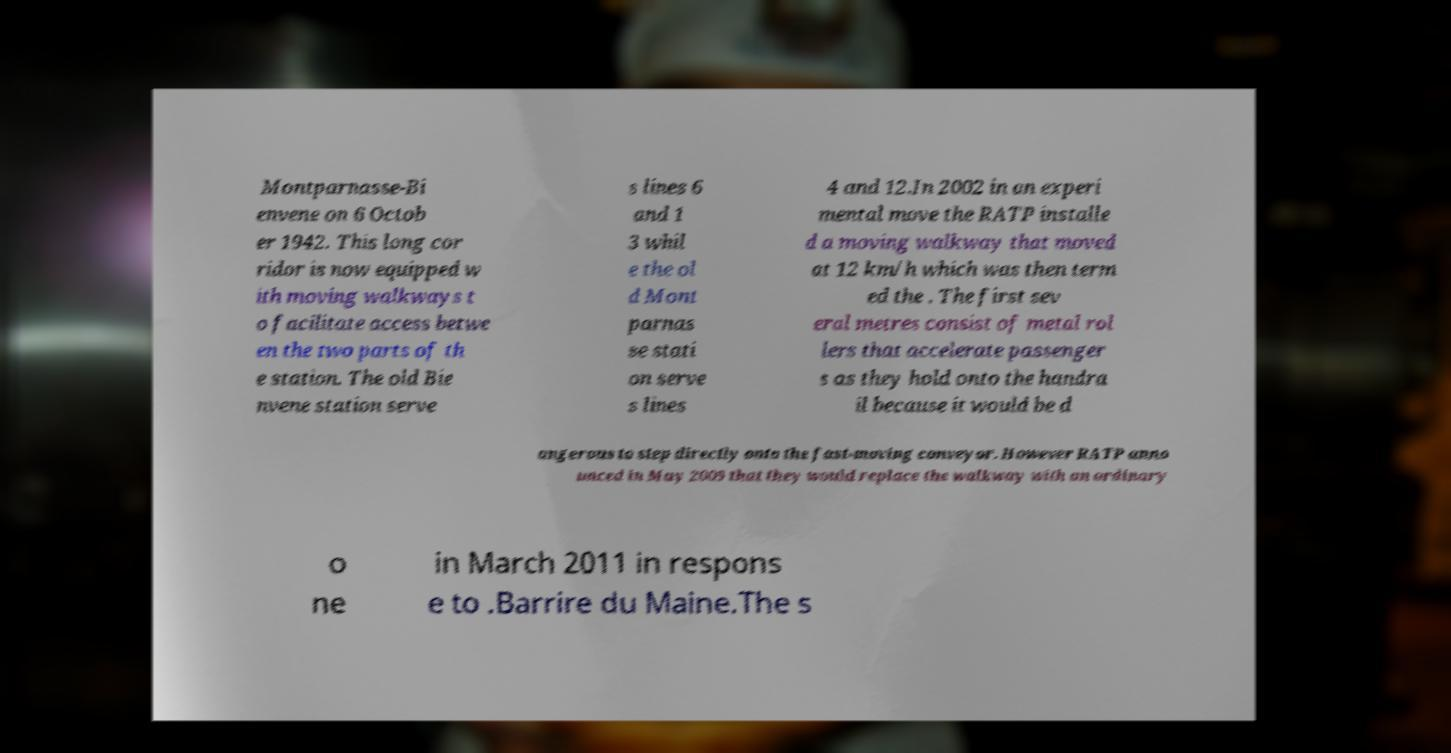For documentation purposes, I need the text within this image transcribed. Could you provide that? Montparnasse-Bi envene on 6 Octob er 1942. This long cor ridor is now equipped w ith moving walkways t o facilitate access betwe en the two parts of th e station. The old Bie nvene station serve s lines 6 and 1 3 whil e the ol d Mont parnas se stati on serve s lines 4 and 12.In 2002 in an experi mental move the RATP installe d a moving walkway that moved at 12 km/h which was then term ed the . The first sev eral metres consist of metal rol lers that accelerate passenger s as they hold onto the handra il because it would be d angerous to step directly onto the fast-moving conveyor. However RATP anno unced in May 2009 that they would replace the walkway with an ordinary o ne in March 2011 in respons e to .Barrire du Maine.The s 